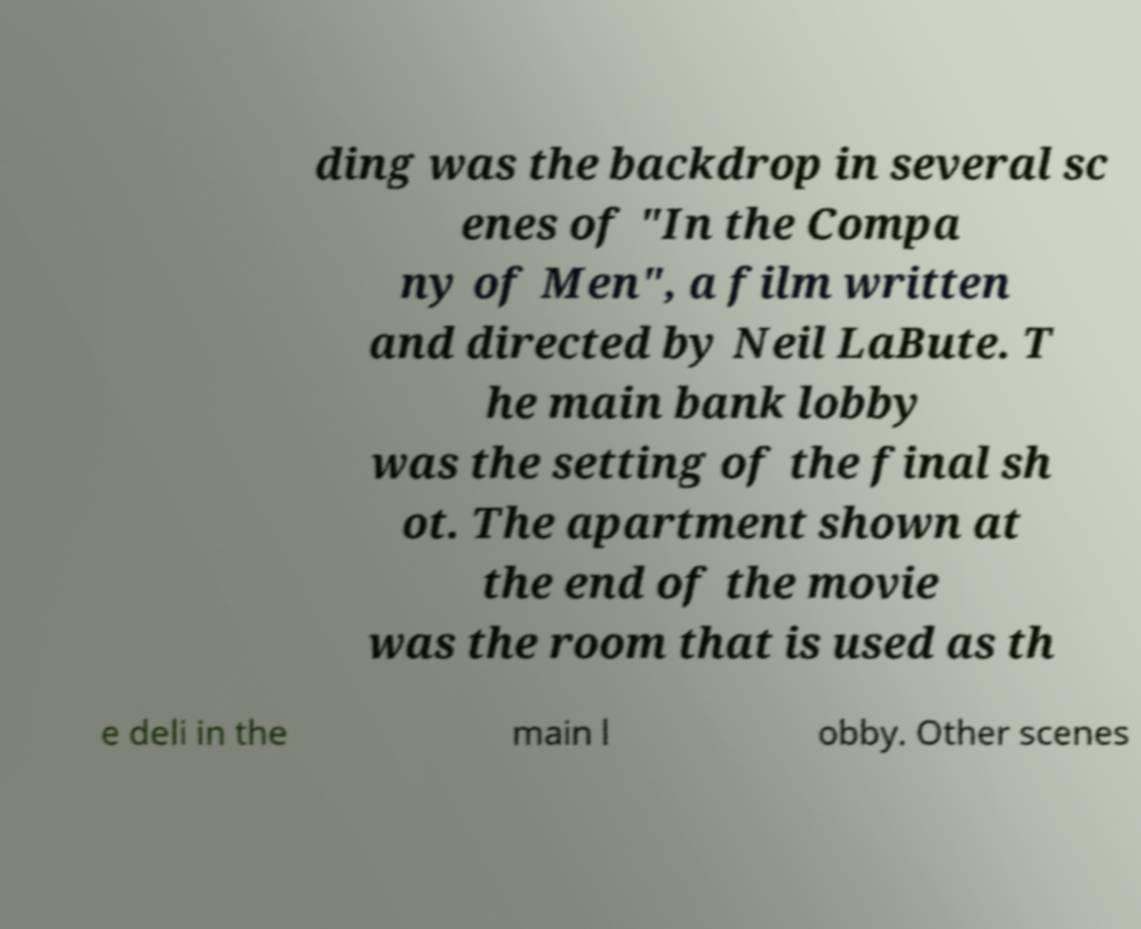Please read and relay the text visible in this image. What does it say? ding was the backdrop in several sc enes of "In the Compa ny of Men", a film written and directed by Neil LaBute. T he main bank lobby was the setting of the final sh ot. The apartment shown at the end of the movie was the room that is used as th e deli in the main l obby. Other scenes 